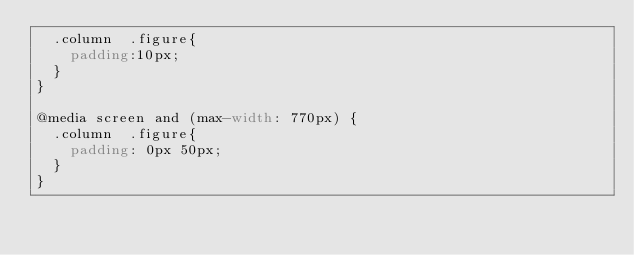<code> <loc_0><loc_0><loc_500><loc_500><_CSS_>  .column  .figure{
    padding:10px;
  }
}

@media screen and (max-width: 770px) {
  .column  .figure{
    padding: 0px 50px;
  }
}
</code> 